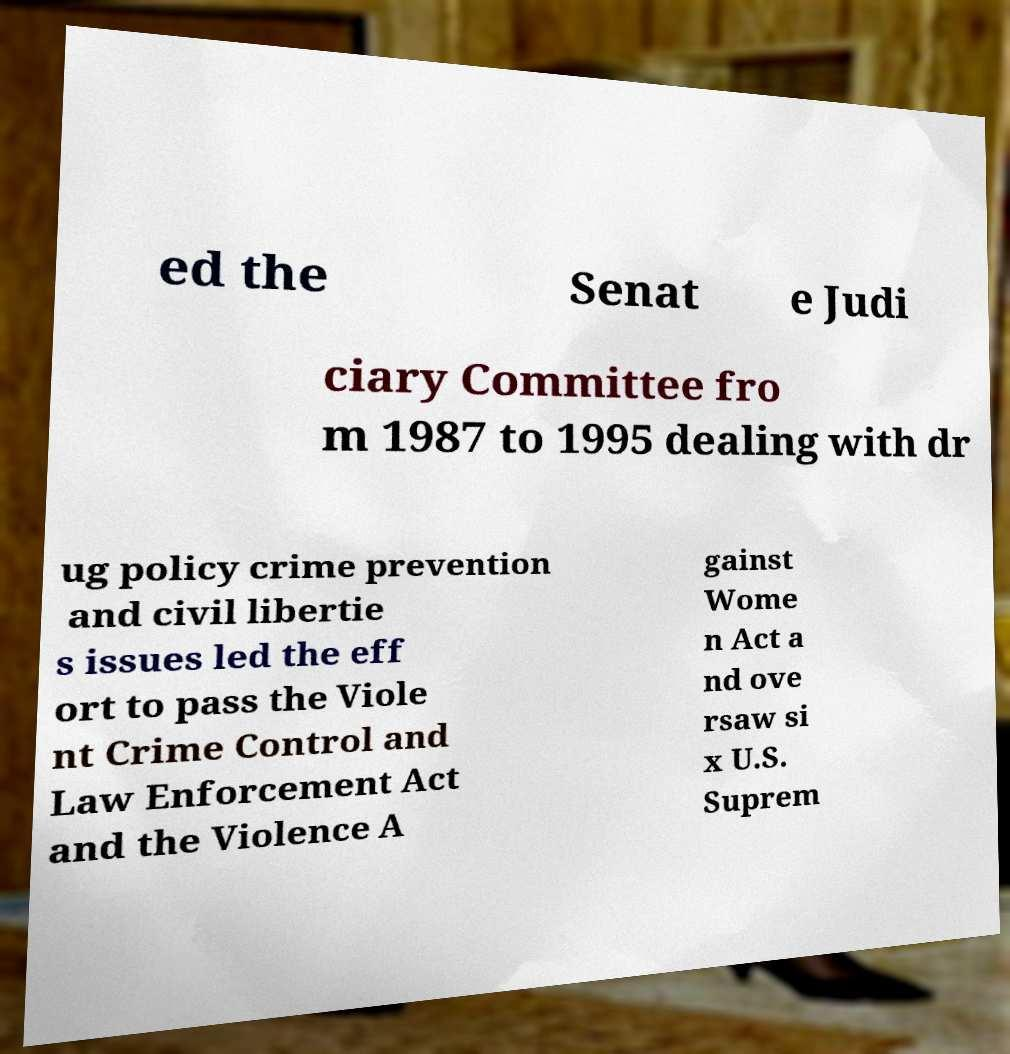There's text embedded in this image that I need extracted. Can you transcribe it verbatim? ed the Senat e Judi ciary Committee fro m 1987 to 1995 dealing with dr ug policy crime prevention and civil libertie s issues led the eff ort to pass the Viole nt Crime Control and Law Enforcement Act and the Violence A gainst Wome n Act a nd ove rsaw si x U.S. Suprem 